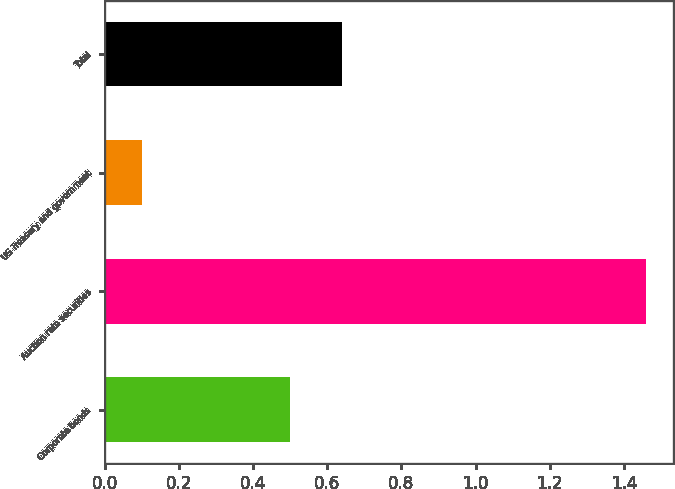Convert chart to OTSL. <chart><loc_0><loc_0><loc_500><loc_500><bar_chart><fcel>Corporate bonds<fcel>Auction rate securities<fcel>US Treasury and government<fcel>Total<nl><fcel>0.5<fcel>1.46<fcel>0.1<fcel>0.64<nl></chart> 